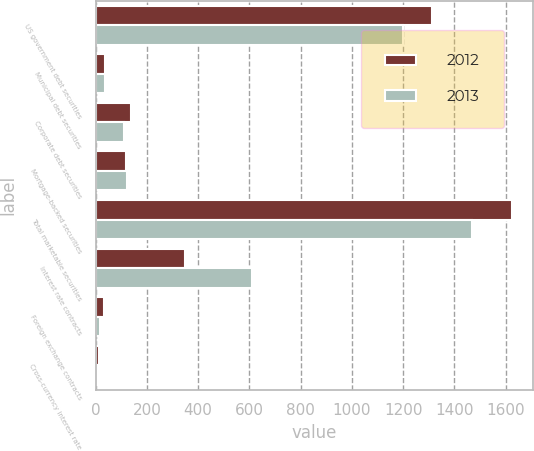Convert chart. <chart><loc_0><loc_0><loc_500><loc_500><stacked_bar_chart><ecel><fcel>US government debt securities<fcel>Municipal debt securities<fcel>Corporate debt securities<fcel>Mortgage-backed securities<fcel>Total marketable securities<fcel>Interest rate contracts<fcel>Foreign exchange contracts<fcel>Cross-currency interest rate<nl><fcel>2012<fcel>1312<fcel>36<fcel>138<fcel>119<fcel>1625<fcel>347<fcel>32<fcel>15<nl><fcel>2013<fcel>1200<fcel>38<fcel>110<fcel>122<fcel>1470<fcel>609<fcel>17<fcel>11<nl></chart> 